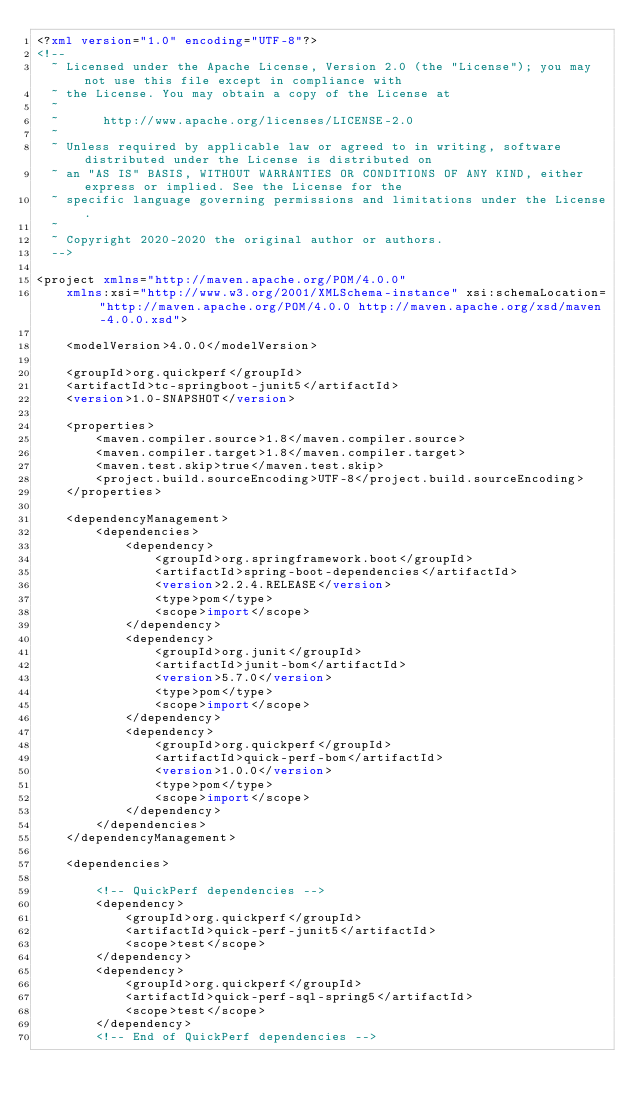<code> <loc_0><loc_0><loc_500><loc_500><_XML_><?xml version="1.0" encoding="UTF-8"?>
<!--
  ~ Licensed under the Apache License, Version 2.0 (the "License"); you may not use this file except in compliance with
  ~ the License. You may obtain a copy of the License at
  ~
  ~      http://www.apache.org/licenses/LICENSE-2.0
  ~
  ~ Unless required by applicable law or agreed to in writing, software distributed under the License is distributed on
  ~ an "AS IS" BASIS, WITHOUT WARRANTIES OR CONDITIONS OF ANY KIND, either express or implied. See the License for the
  ~ specific language governing permissions and limitations under the License.
  ~
  ~ Copyright 2020-2020 the original author or authors.
  -->

<project xmlns="http://maven.apache.org/POM/4.0.0" 
    xmlns:xsi="http://www.w3.org/2001/XMLSchema-instance" xsi:schemaLocation="http://maven.apache.org/POM/4.0.0 http://maven.apache.org/xsd/maven-4.0.0.xsd">

    <modelVersion>4.0.0</modelVersion>

    <groupId>org.quickperf</groupId>
    <artifactId>tc-springboot-junit5</artifactId>
    <version>1.0-SNAPSHOT</version>

    <properties>
        <maven.compiler.source>1.8</maven.compiler.source>
        <maven.compiler.target>1.8</maven.compiler.target>
        <maven.test.skip>true</maven.test.skip>
        <project.build.sourceEncoding>UTF-8</project.build.sourceEncoding>
    </properties>

    <dependencyManagement>
        <dependencies>
            <dependency>
                <groupId>org.springframework.boot</groupId>
                <artifactId>spring-boot-dependencies</artifactId>
                <version>2.2.4.RELEASE</version>
                <type>pom</type>
                <scope>import</scope>
            </dependency>
            <dependency>
                <groupId>org.junit</groupId>
                <artifactId>junit-bom</artifactId>
                <version>5.7.0</version>
                <type>pom</type>
                <scope>import</scope>
            </dependency>
            <dependency>
                <groupId>org.quickperf</groupId>
                <artifactId>quick-perf-bom</artifactId>
                <version>1.0.0</version>
                <type>pom</type>
                <scope>import</scope>
            </dependency>
        </dependencies>
    </dependencyManagement>

    <dependencies>

        <!-- QuickPerf dependencies -->
        <dependency>
            <groupId>org.quickperf</groupId>
            <artifactId>quick-perf-junit5</artifactId>
            <scope>test</scope>
        </dependency>
        <dependency>
            <groupId>org.quickperf</groupId>
            <artifactId>quick-perf-sql-spring5</artifactId>
            <scope>test</scope>
        </dependency>
        <!-- End of QuickPerf dependencies -->
</code> 